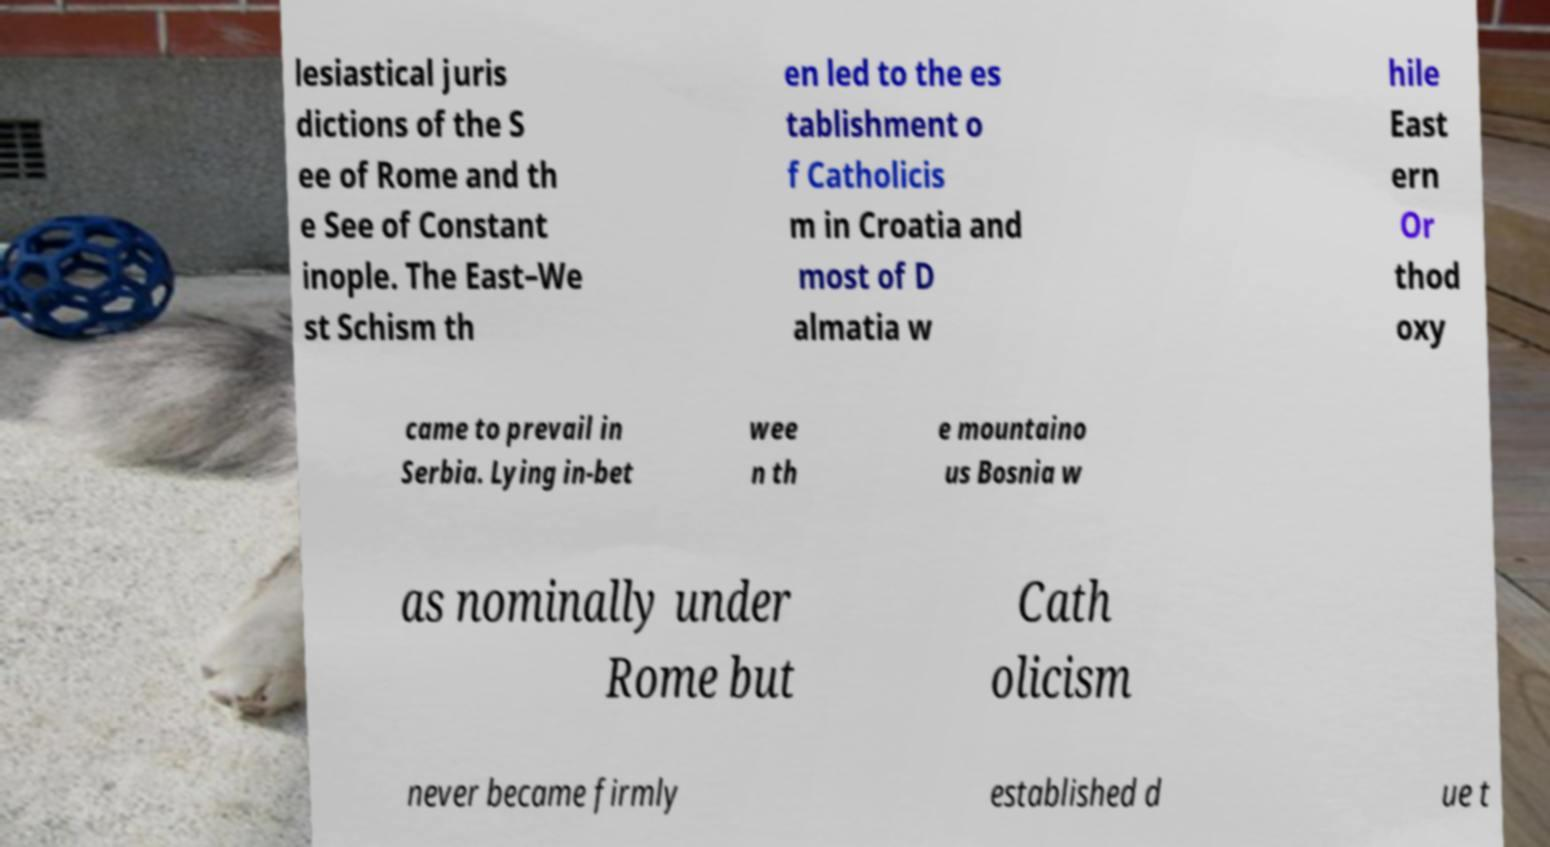There's text embedded in this image that I need extracted. Can you transcribe it verbatim? lesiastical juris dictions of the S ee of Rome and th e See of Constant inople. The East–We st Schism th en led to the es tablishment o f Catholicis m in Croatia and most of D almatia w hile East ern Or thod oxy came to prevail in Serbia. Lying in-bet wee n th e mountaino us Bosnia w as nominally under Rome but Cath olicism never became firmly established d ue t 